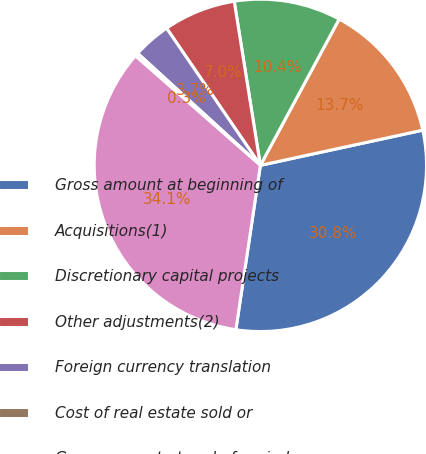<chart> <loc_0><loc_0><loc_500><loc_500><pie_chart><fcel>Gross amount at beginning of<fcel>Acquisitions(1)<fcel>Discretionary capital projects<fcel>Other adjustments(2)<fcel>Foreign currency translation<fcel>Cost of real estate sold or<fcel>Gross amount at end of period<nl><fcel>30.75%<fcel>13.74%<fcel>10.38%<fcel>7.03%<fcel>3.68%<fcel>0.32%<fcel>34.1%<nl></chart> 